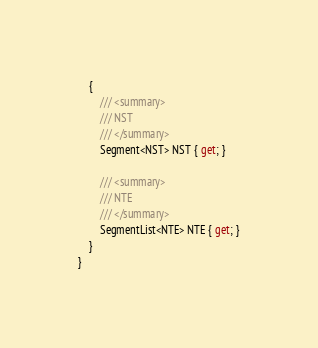<code> <loc_0><loc_0><loc_500><loc_500><_C#_>    {
        /// <summary>
        /// NST
        /// </summary>
        Segment<NST> NST { get; }

        /// <summary>
        /// NTE
        /// </summary>
        SegmentList<NTE> NTE { get; }
    }
}</code> 